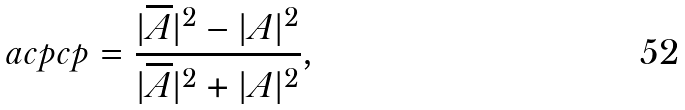<formula> <loc_0><loc_0><loc_500><loc_500>\ a c p c p = \frac { | \overline { A } | ^ { 2 } - | A | ^ { 2 } } { | \overline { A } | ^ { 2 } + | A | ^ { 2 } } ,</formula> 